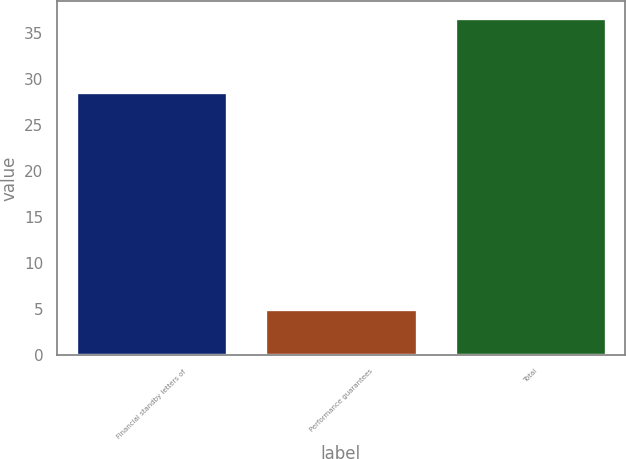<chart> <loc_0><loc_0><loc_500><loc_500><bar_chart><fcel>Financial standby letters of<fcel>Performance guarantees<fcel>Total<nl><fcel>28.6<fcel>5<fcel>36.7<nl></chart> 